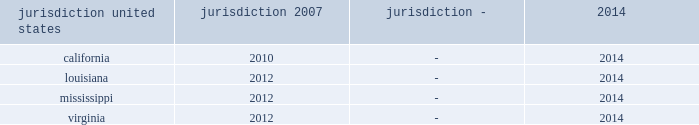Interest and penalties with respect to unrecognized tax benefits were $ 3 million as of each of december 31 , 2015 and 2014 .
During 2013 , the company recorded a reduction of $ 14 million to its liability for uncertain tax positions related to a change approved by the irs for the allocation of interest costs to long term construction contracts at ingalls .
This change was made on a prospective basis only and did not impact the tax returns filed for years prior to 2013 .
The table summarizes the tax years that are either currently under examination or remain open under the applicable statute of limitations and subject to examination by the major tax jurisdictions in which the company operates: .
Although the company believes it has adequately provided for all uncertain tax positions , amounts asserted by taxing authorities could be greater than the company's accrued position .
Accordingly , additional provisions for federal and state income tax related matters could be recorded in the future as revised estimates are made or the underlying matters are effectively settled or otherwise resolved .
Conversely , the company could settle positions with the tax authorities for amounts lower than have been accrued .
The company believes that it is reasonably possible that during the next 12 months the company's liability for uncertain tax positions may decrease by approximately $ 2 million due to statute of limitation expirations .
The company recognizes accrued interest and penalties related to uncertain tax positions in income tax expense .
The irs is currently conducting an examination of northrop grumman's consolidated tax returns , of which hii was part , for the years 2007 through the spin-off .
During 2013 the company entered into the pre-compliance assurance process with the irs for years 2011 and 2012 .
The company is part of the irs compliance assurance process program for the 2014 , 2015 , and 2016 tax years .
Open tax years related to state jurisdictions remain subject to examination .
As of march 31 , 2011 , the date of the spin-off , the company's liability for uncertain tax positions was approximately $ 4 million , net of federal benefit , which related solely to state income tax positions .
Under the terms of the separation agreement , northrop grumman is obligated to reimburse hii for any settlement liabilities paid by hii to any government authority for tax periods prior to the spin-off , which include state income taxes .
As a result , the company recorded in other assets a reimbursement receivable of approximately $ 4 million , net of federal benefit , related to uncertain tax positions for state income taxes as of the date of the spin-off .
In 2014 , the statute of limitations expired for the $ 4 million liability related to state uncertain tax positions as of the spin-off date .
Accordingly , the $ 4 million liability and the associated reimbursement receivable were written off .
On september 13 , 2013 , the treasury department and the internal revenue service issued final regulations regarding the deduction and capitalization of amounts paid to acquire , produce , improve , or dispose of tangible personal property .
These regulations are generally effective for tax years beginning on or after january 1 , 2014 .
The application of these regulations did not have a material impact on the company's consolidated financial statements .
Deferred income taxes - deferred income taxes reflect the net tax effects of temporary differences between the carrying amounts of assets and liabilities for financial reporting purposes and for income tax purposes .
Such amounts are classified in the consolidated statements of financial position as current or non-current assets or liabilities based upon the classification of the related assets and liabilities. .
What is the percent of the average unrecognized tax benefits fro 2014 and 2015 to the recorded reduction in its liability for uncertain tax positions based on the approved irs allocation? 
Computations: (3 / 14)
Answer: 0.21429. 